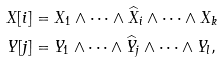<formula> <loc_0><loc_0><loc_500><loc_500>X [ i ] & = X _ { 1 } \wedge \cdots \wedge \widehat { X } _ { i } \wedge \cdots \wedge X _ { k } \\ Y [ j ] & = Y _ { 1 } \wedge \cdots \wedge \widehat { Y } _ { j } \wedge \cdots \wedge Y _ { l } ,</formula> 